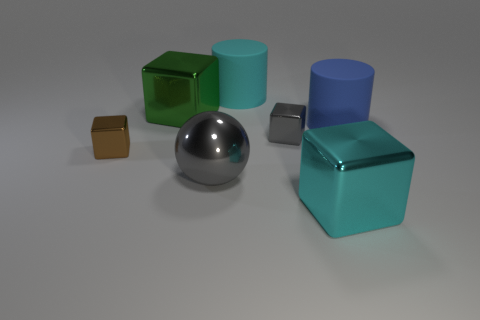Are there any gray things that have the same size as the brown cube?
Provide a short and direct response. Yes. Are the cyan cube and the big cube behind the cyan block made of the same material?
Offer a terse response. Yes. There is a large cube in front of the gray metal sphere; what material is it?
Make the answer very short. Metal. What is the size of the sphere?
Your answer should be very brief. Large. Do the cube that is in front of the gray sphere and the green metal object behind the metal sphere have the same size?
Your answer should be very brief. Yes. There is a brown metallic thing that is the same shape as the large green thing; what is its size?
Your answer should be compact. Small. There is a gray block; does it have the same size as the rubber cylinder behind the large green thing?
Provide a short and direct response. No. There is a metal block on the right side of the tiny gray object; is there a big cyan object to the left of it?
Your response must be concise. Yes. What is the shape of the cyan object in front of the big cyan matte object?
Offer a terse response. Cube. The small block that is right of the tiny block that is to the left of the gray metallic block is what color?
Your response must be concise. Gray. 